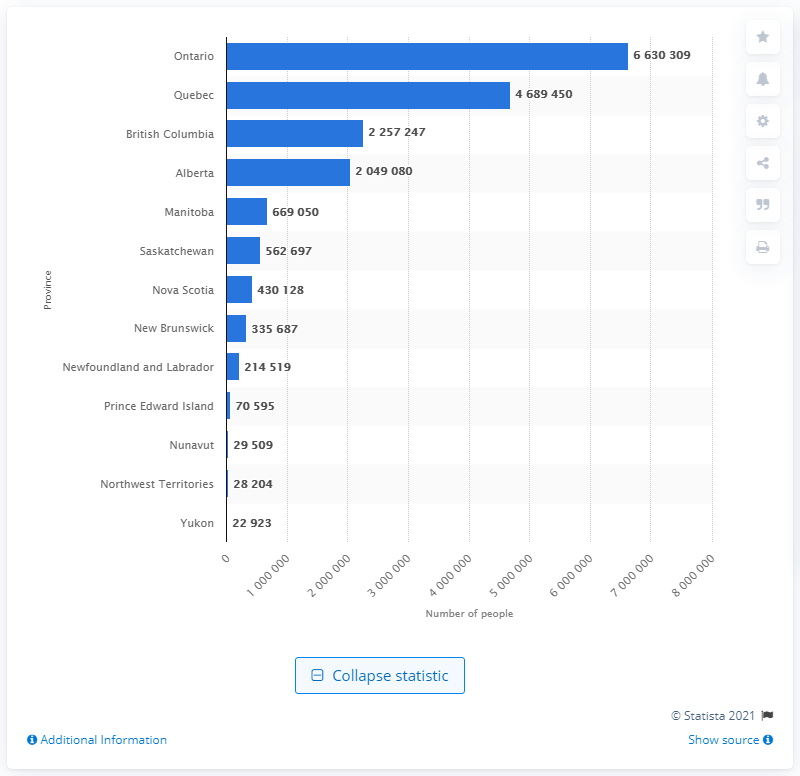Mention a couple of crucial points in this snapshot. In 2020, Ontario had the highest number of single individuals living in it. In 2020, there were approximately 6,630,309 single individuals living in Ontario. 